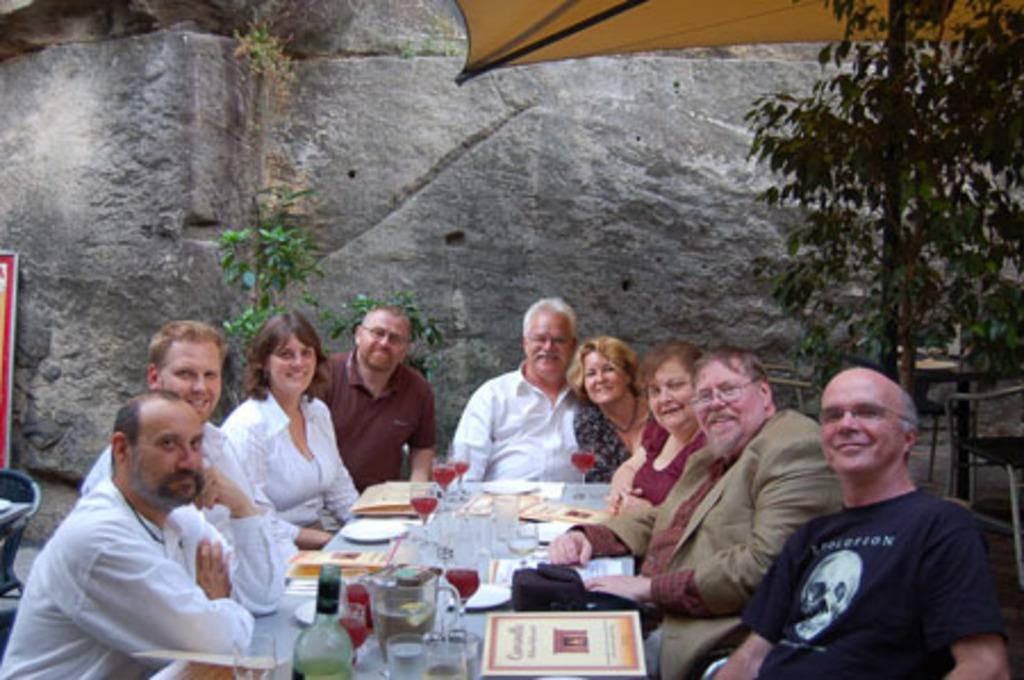How many people are in the image? There is a group of people in the image. What are the people doing in the image? The people are sitting in the image. What is in front of the people? There is a table in front of the people. What can be seen on the table? Wine glasses are present on the table. What can be seen in the background of the image? There is a rock and a plant in the background of the image. What is the title of the book that the baby is reading in the image? There is no baby or book present in the image. 